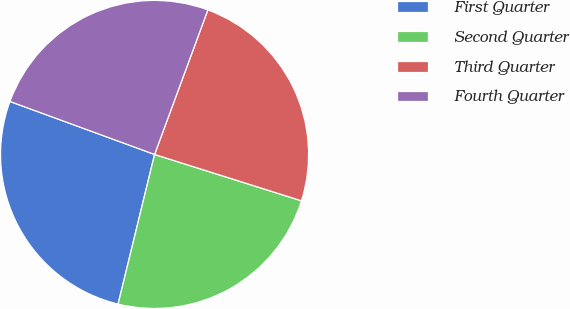Convert chart. <chart><loc_0><loc_0><loc_500><loc_500><pie_chart><fcel>First Quarter<fcel>Second Quarter<fcel>Third Quarter<fcel>Fourth Quarter<nl><fcel>26.78%<fcel>23.94%<fcel>24.24%<fcel>25.03%<nl></chart> 